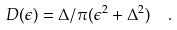<formula> <loc_0><loc_0><loc_500><loc_500>D ( \epsilon ) = \Delta / \pi ( \epsilon ^ { 2 } + \Delta ^ { 2 } ) \ \ .</formula> 